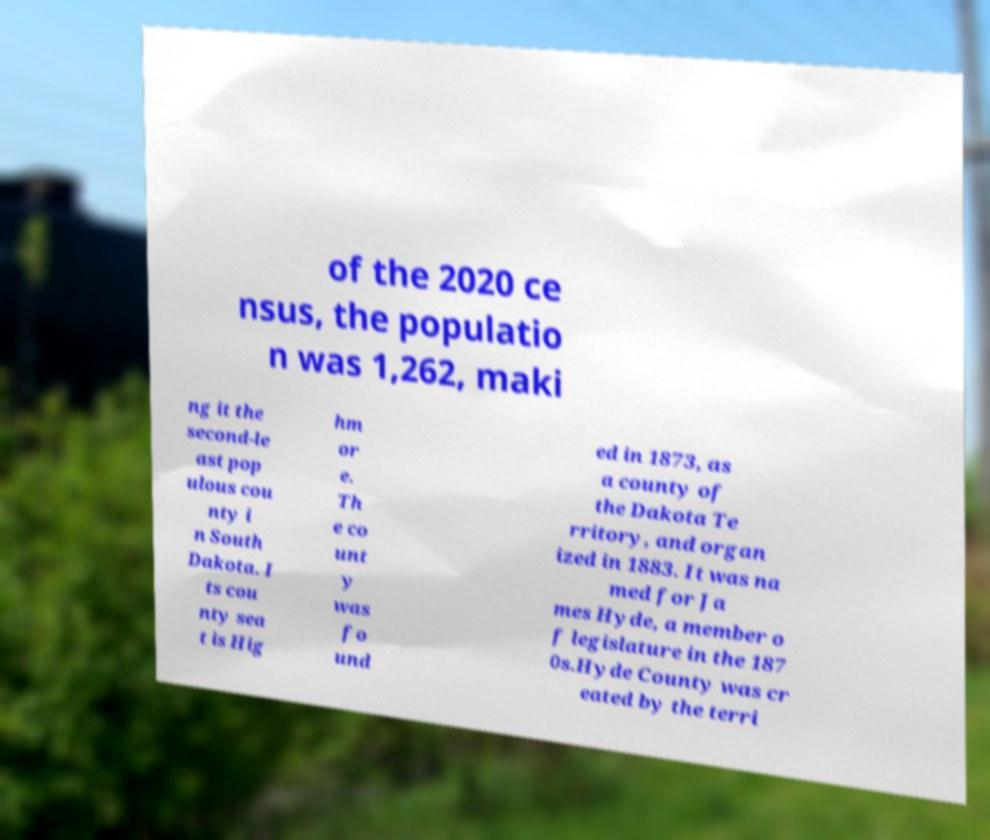Can you accurately transcribe the text from the provided image for me? of the 2020 ce nsus, the populatio n was 1,262, maki ng it the second-le ast pop ulous cou nty i n South Dakota. I ts cou nty sea t is Hig hm or e. Th e co unt y was fo und ed in 1873, as a county of the Dakota Te rritory, and organ ized in 1883. It was na med for Ja mes Hyde, a member o f legislature in the 187 0s.Hyde County was cr eated by the terri 